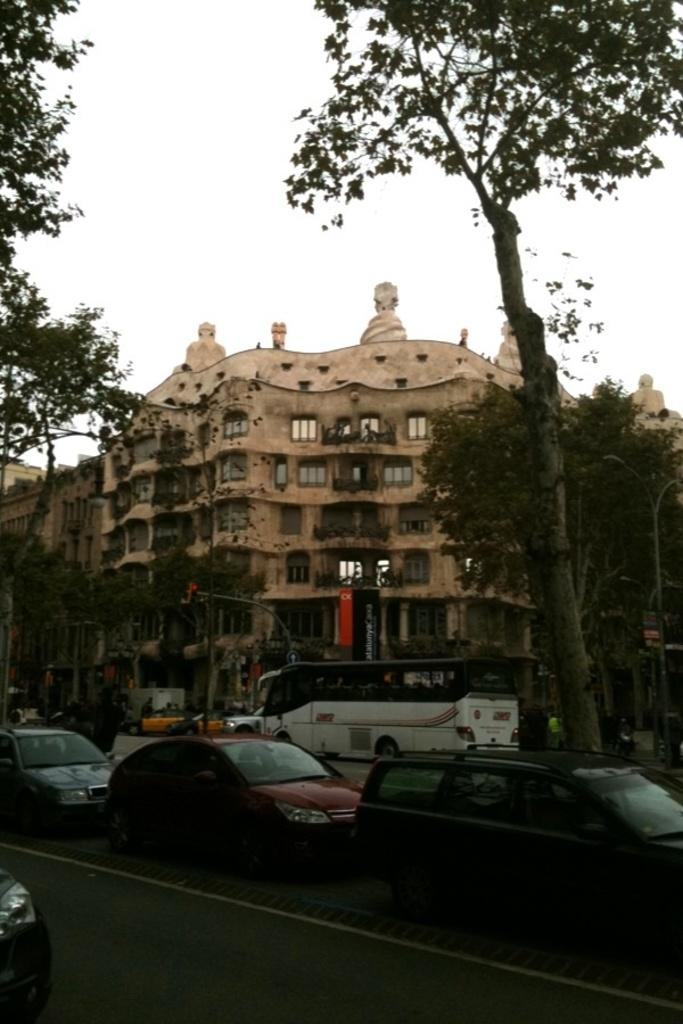What type of vehicles can be seen parked on the road in the image? There are cars and a bus parked on the road in the image. What else can be seen in the image besides vehicles? There are trees and buildings visible in the image. What is the condition of the sky in the image? The sky is clear in the image. Can you see a donkey walking along the coast in the image? There is no donkey or coastline present in the image. 